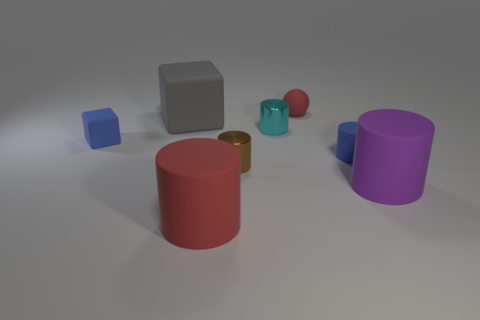If you were to use these objects in a game, how would you assign points to them based on their size and color? In a hypothetical game, points could be assigned by considering both the size and color rarity of the objects. For instance, larger objects like the red cylinder could be worth 10 points, medium-sized objects like the purple cylinder 5 points, and smaller objects like the small teal cylinder 2 points. Rare colors, like teal or gold, might yield bonus points, encouraging players to seek out these objects for higher scores. 